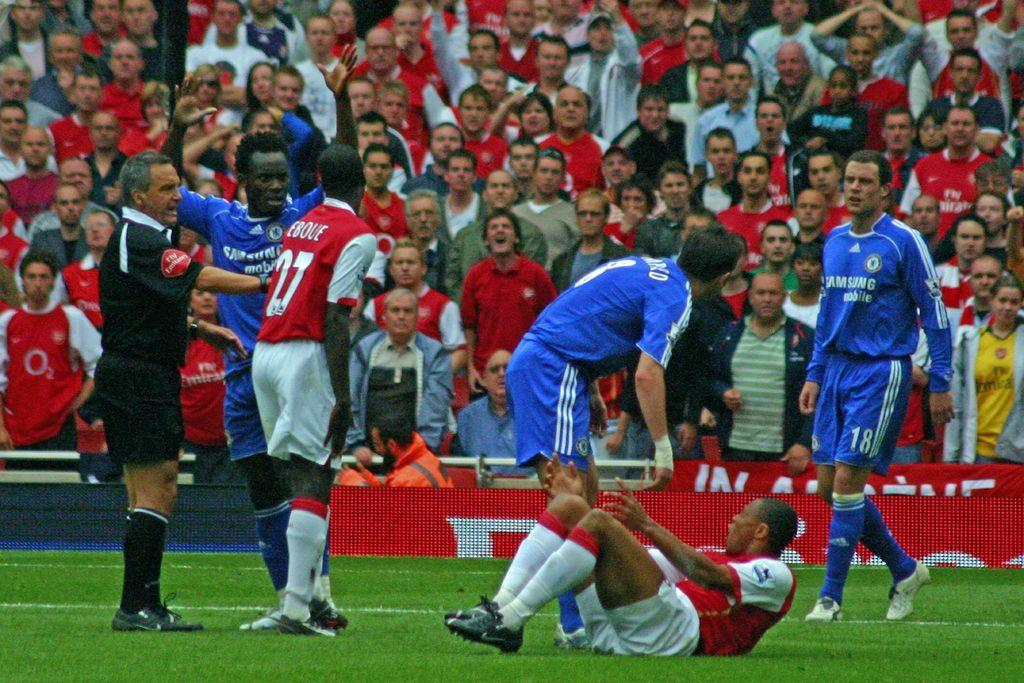Provide a one-sentence caption for the provided image. The player in the red 27 jersey argues with a player of the opposite team. 